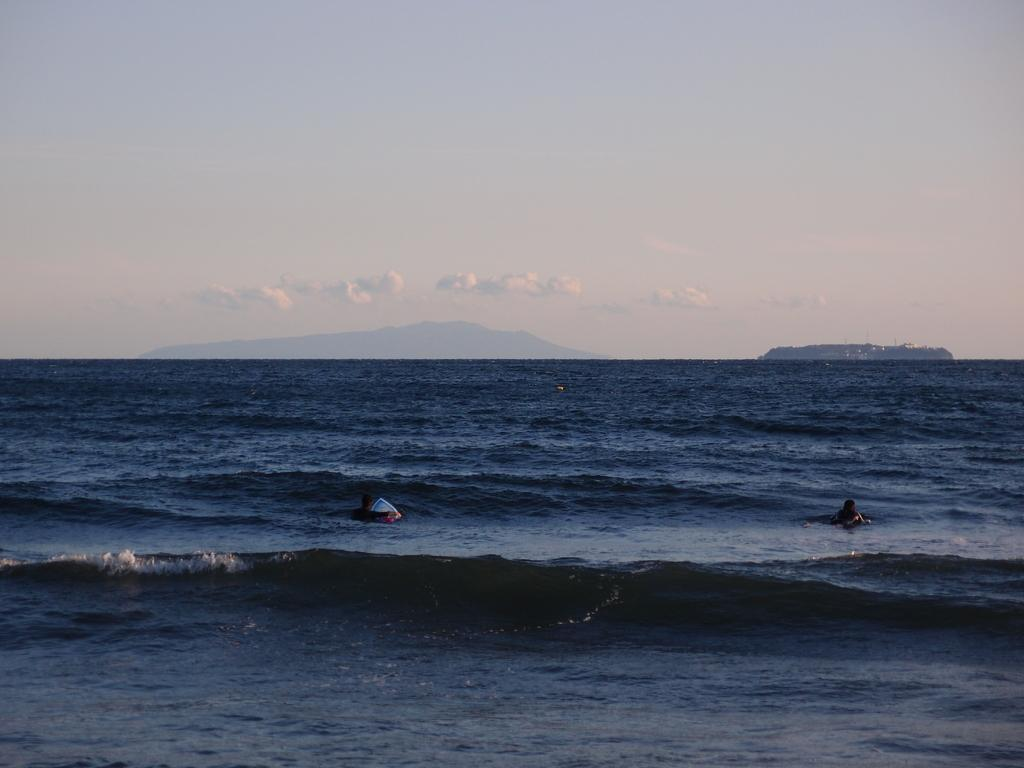What are the people in the image doing? The people in the image are in the water. What can be seen in the background of the image? The sky is visible in the background of the image. What type of goat can be seen climbing the box in the image? There is no goat or box present in the image; it features people in the water with the sky visible in the background. 